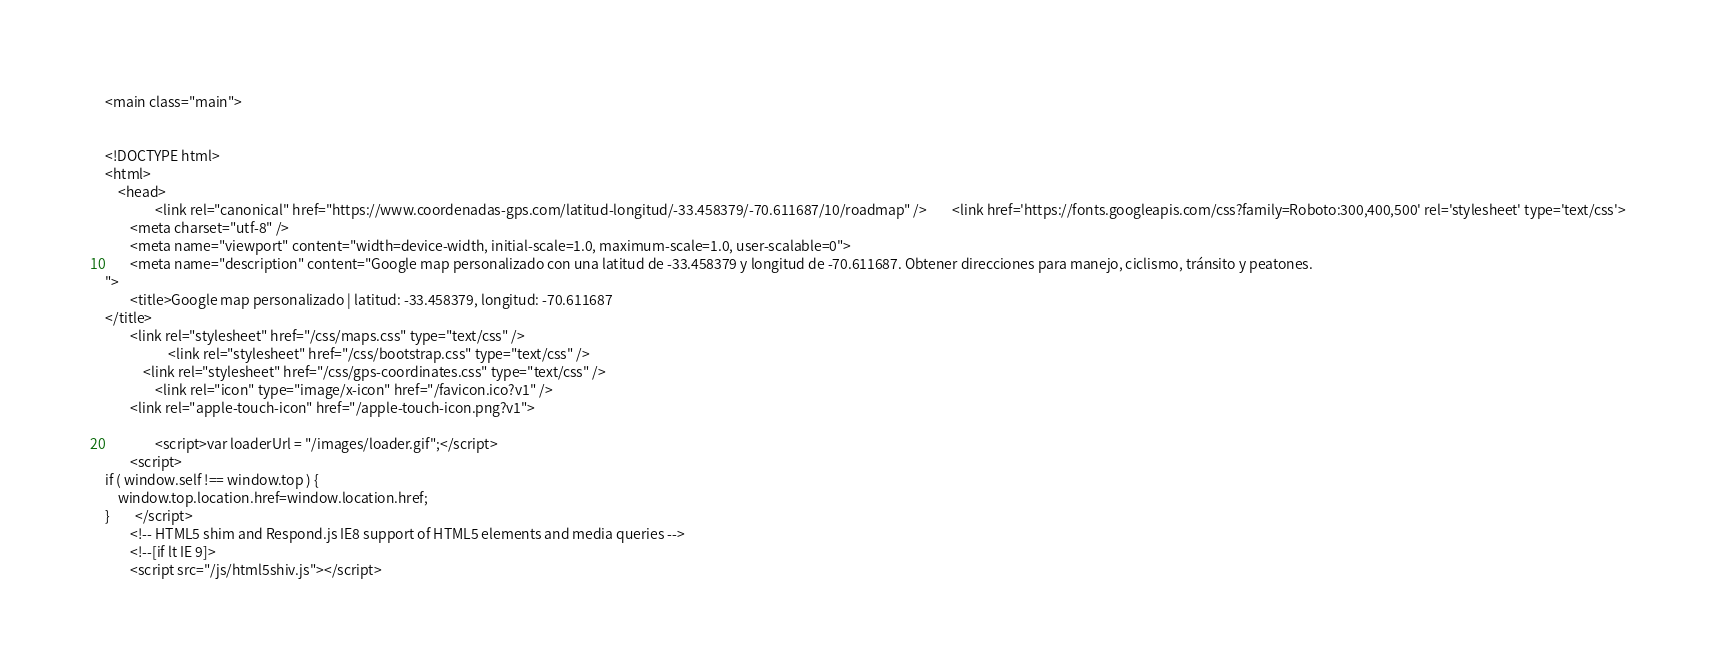Convert code to text. <code><loc_0><loc_0><loc_500><loc_500><_PHP_><main class="main">
          

<!DOCTYPE html>
<html>
    <head>
                <link rel="canonical" href="https://www.coordenadas-gps.com/latitud-longitud/-33.458379/-70.611687/10/roadmap" />        <link href='https://fonts.googleapis.com/css?family=Roboto:300,400,500' rel='stylesheet' type='text/css'>
        <meta charset="utf-8" />
        <meta name="viewport" content="width=device-width, initial-scale=1.0, maximum-scale=1.0, user-scalable=0">
        <meta name="description" content="Google map personalizado con una latitud de -33.458379 y longitud de -70.611687. Obtener direcciones para manejo, ciclismo, tránsito y peatones.
">
        <title>Google map personalizado | latitud: -33.458379, longitud: -70.611687
</title>
        <link rel="stylesheet" href="/css/maps.css" type="text/css" />
                    <link rel="stylesheet" href="/css/bootstrap.css" type="text/css" />
            <link rel="stylesheet" href="/css/gps-coordinates.css" type="text/css" />
                <link rel="icon" type="image/x-icon" href="/favicon.ico?v1" />
        <link rel="apple-touch-icon" href="/apple-touch-icon.png?v1">
        
                <script>var loaderUrl = "/images/loader.gif";</script>
        <script>
if ( window.self !== window.top ) {
    window.top.location.href=window.location.href;
}        </script>
        <!-- HTML5 shim and Respond.js IE8 support of HTML5 elements and media queries -->
        <!--[if lt IE 9]>
        <script src="/js/html5shiv.js"></script></code> 